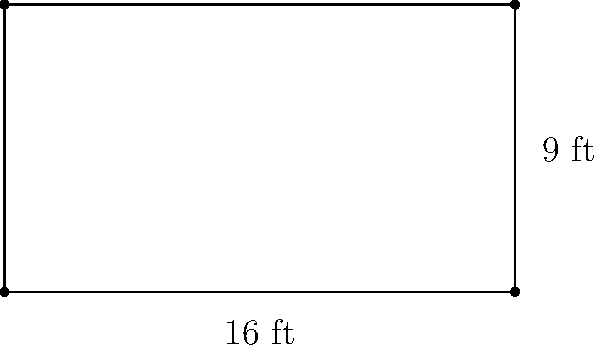As a screenwriter collaborating with a YouTuber on video essays about screenwriting techniques, you're discussing aspect ratios. You need to calculate the area of a movie screen for a visual example. If the screen has a width of 16 feet and a height of 9 feet (representing a common 16:9 aspect ratio), what is the total area of the screen in square feet? To calculate the area of a rectangular screen, we need to multiply its width by its height. Let's break it down step-by-step:

1. Identify the given dimensions:
   - Width = 16 feet
   - Height = 9 feet

2. Use the formula for the area of a rectangle:
   $$ \text{Area} = \text{width} \times \text{height} $$

3. Plug in the values:
   $$ \text{Area} = 16 \text{ ft} \times 9 \text{ ft} $$

4. Perform the multiplication:
   $$ \text{Area} = 144 \text{ sq ft} $$

Therefore, the total area of the movie screen is 144 square feet.
Answer: 144 sq ft 